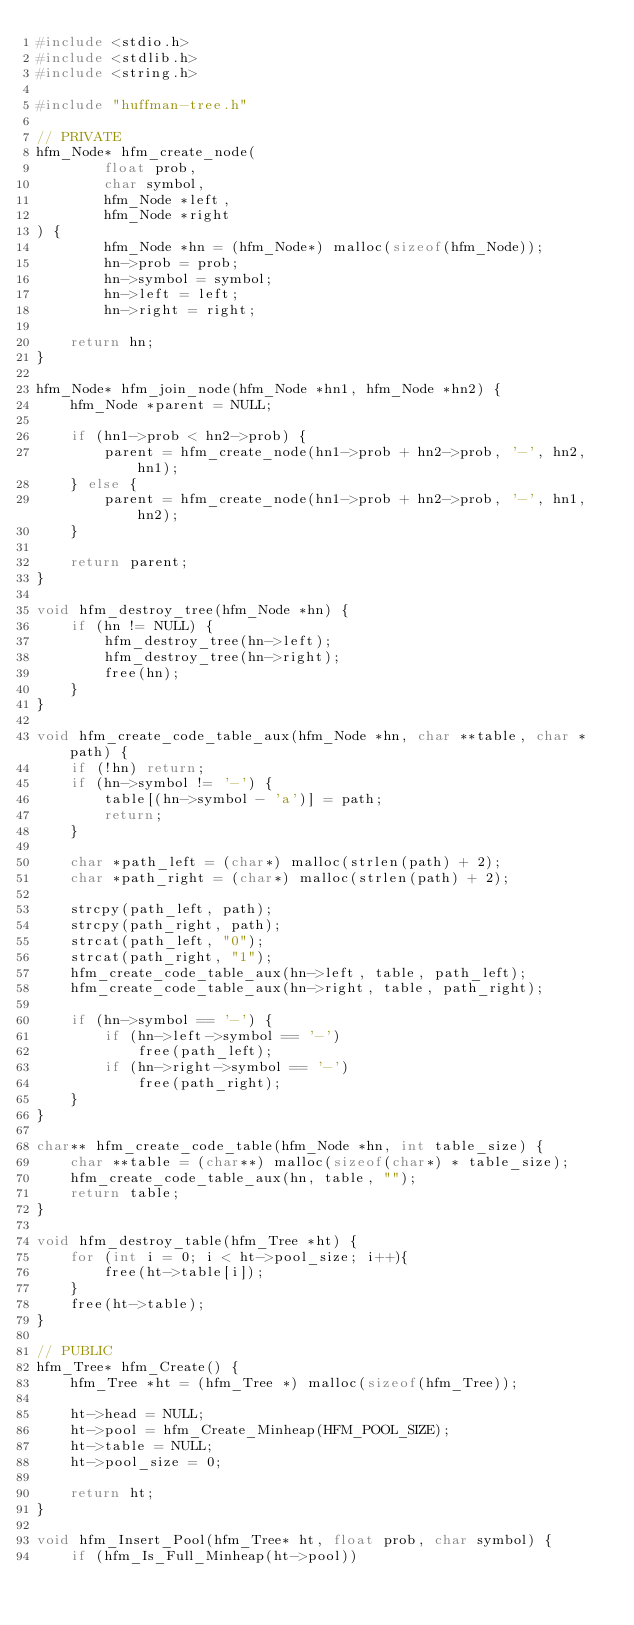Convert code to text. <code><loc_0><loc_0><loc_500><loc_500><_C_>#include <stdio.h>
#include <stdlib.h>
#include <string.h>

#include "huffman-tree.h"

// PRIVATE
hfm_Node* hfm_create_node(
        float prob,
        char symbol,
        hfm_Node *left,
        hfm_Node *right
) {
        hfm_Node *hn = (hfm_Node*) malloc(sizeof(hfm_Node));
        hn->prob = prob;
        hn->symbol = symbol;
        hn->left = left;
        hn->right = right;

    return hn;
}

hfm_Node* hfm_join_node(hfm_Node *hn1, hfm_Node *hn2) {
    hfm_Node *parent = NULL;

    if (hn1->prob < hn2->prob) {
        parent = hfm_create_node(hn1->prob + hn2->prob, '-', hn2, hn1);
    } else {
        parent = hfm_create_node(hn1->prob + hn2->prob, '-', hn1, hn2);
    }

    return parent;
}

void hfm_destroy_tree(hfm_Node *hn) {
    if (hn != NULL) {
        hfm_destroy_tree(hn->left);
        hfm_destroy_tree(hn->right);
        free(hn);
    }
}

void hfm_create_code_table_aux(hfm_Node *hn, char **table, char *path) {
    if (!hn) return;
    if (hn->symbol != '-') {
        table[(hn->symbol - 'a')] = path;
        return;
    }

    char *path_left = (char*) malloc(strlen(path) + 2);
    char *path_right = (char*) malloc(strlen(path) + 2);

    strcpy(path_left, path);
    strcpy(path_right, path);
    strcat(path_left, "0");
    strcat(path_right, "1");
    hfm_create_code_table_aux(hn->left, table, path_left);
    hfm_create_code_table_aux(hn->right, table, path_right);

    if (hn->symbol == '-') {
        if (hn->left->symbol == '-')
            free(path_left);
        if (hn->right->symbol == '-')
            free(path_right);
    }
}

char** hfm_create_code_table(hfm_Node *hn, int table_size) {
    char **table = (char**) malloc(sizeof(char*) * table_size);
    hfm_create_code_table_aux(hn, table, "");
    return table;
}

void hfm_destroy_table(hfm_Tree *ht) {
    for (int i = 0; i < ht->pool_size; i++){
        free(ht->table[i]);
    }
    free(ht->table);
}

// PUBLIC
hfm_Tree* hfm_Create() {
    hfm_Tree *ht = (hfm_Tree *) malloc(sizeof(hfm_Tree));

    ht->head = NULL;
    ht->pool = hfm_Create_Minheap(HFM_POOL_SIZE);
    ht->table = NULL;
    ht->pool_size = 0;

    return ht;
}

void hfm_Insert_Pool(hfm_Tree* ht, float prob, char symbol) {
    if (hfm_Is_Full_Minheap(ht->pool))</code> 